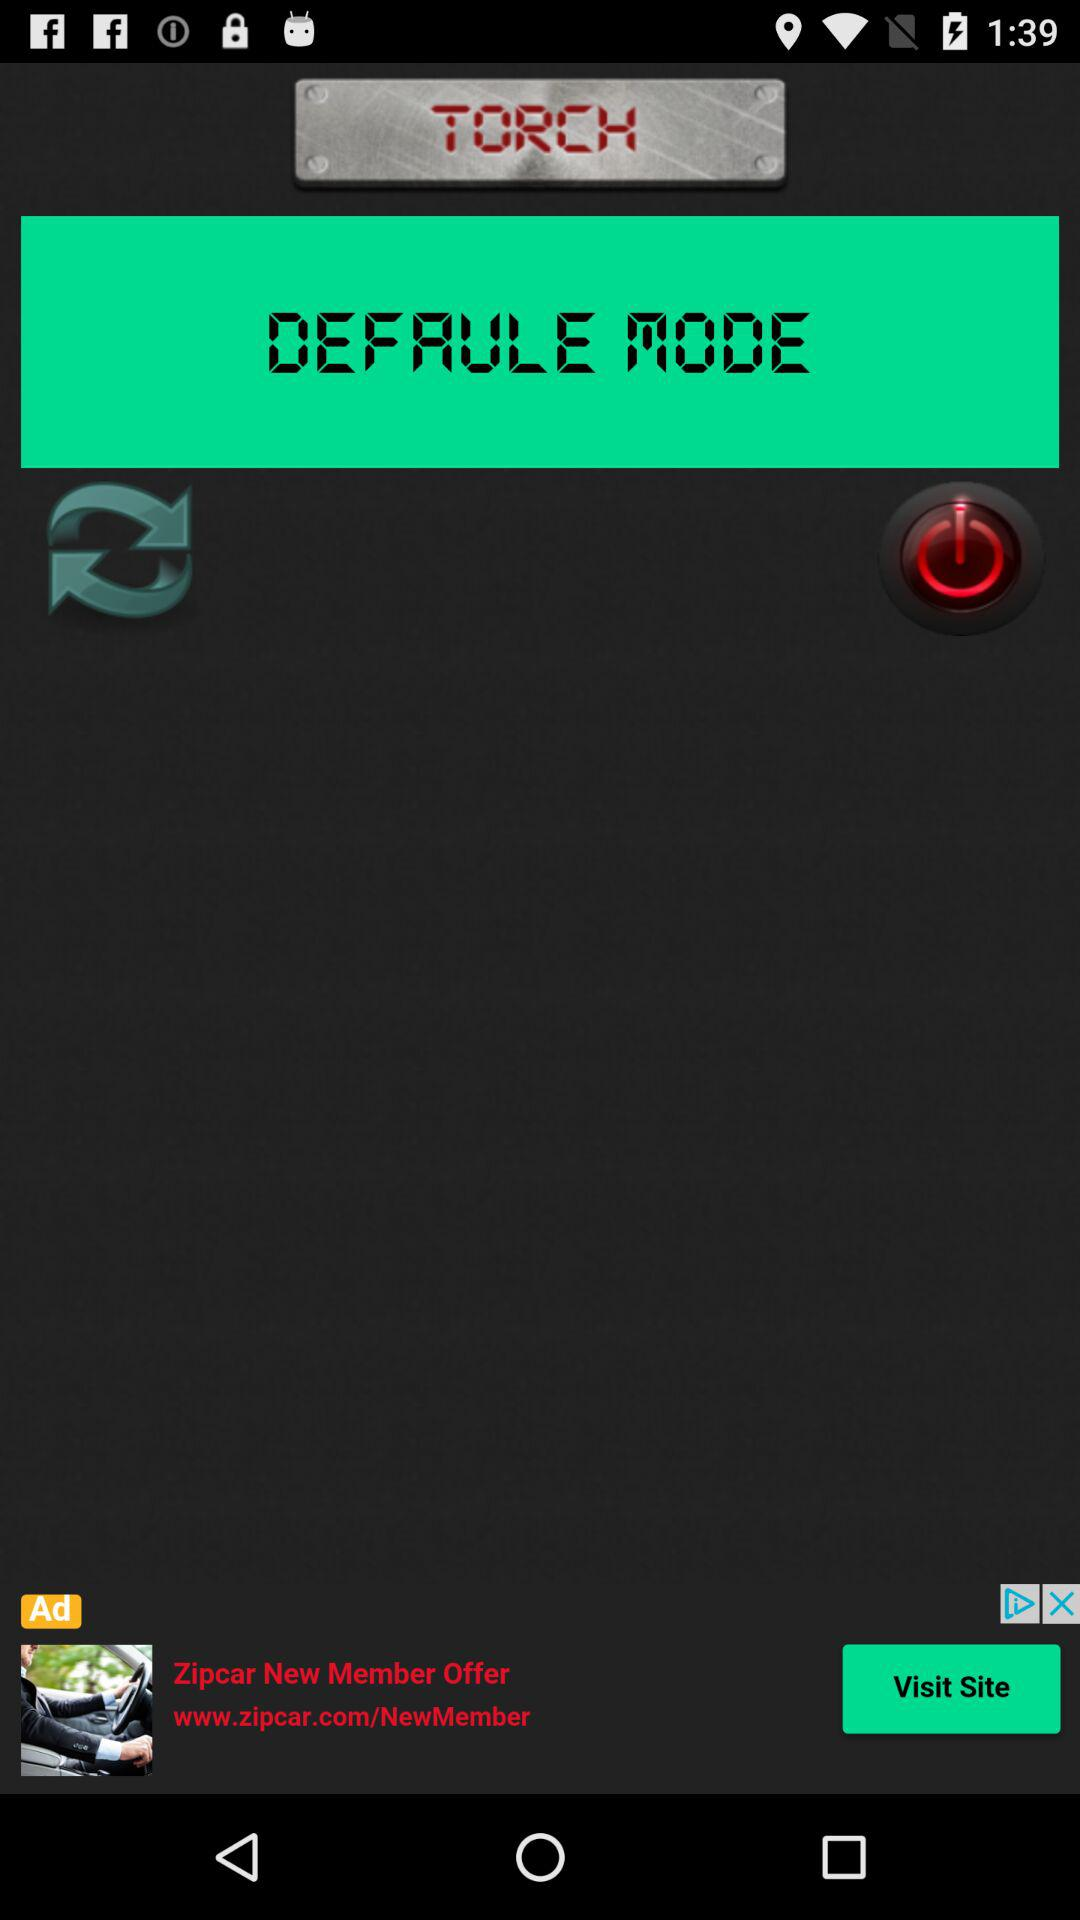What is the mentioned mode? The mentioned mode is "DEFAULE MODE". 